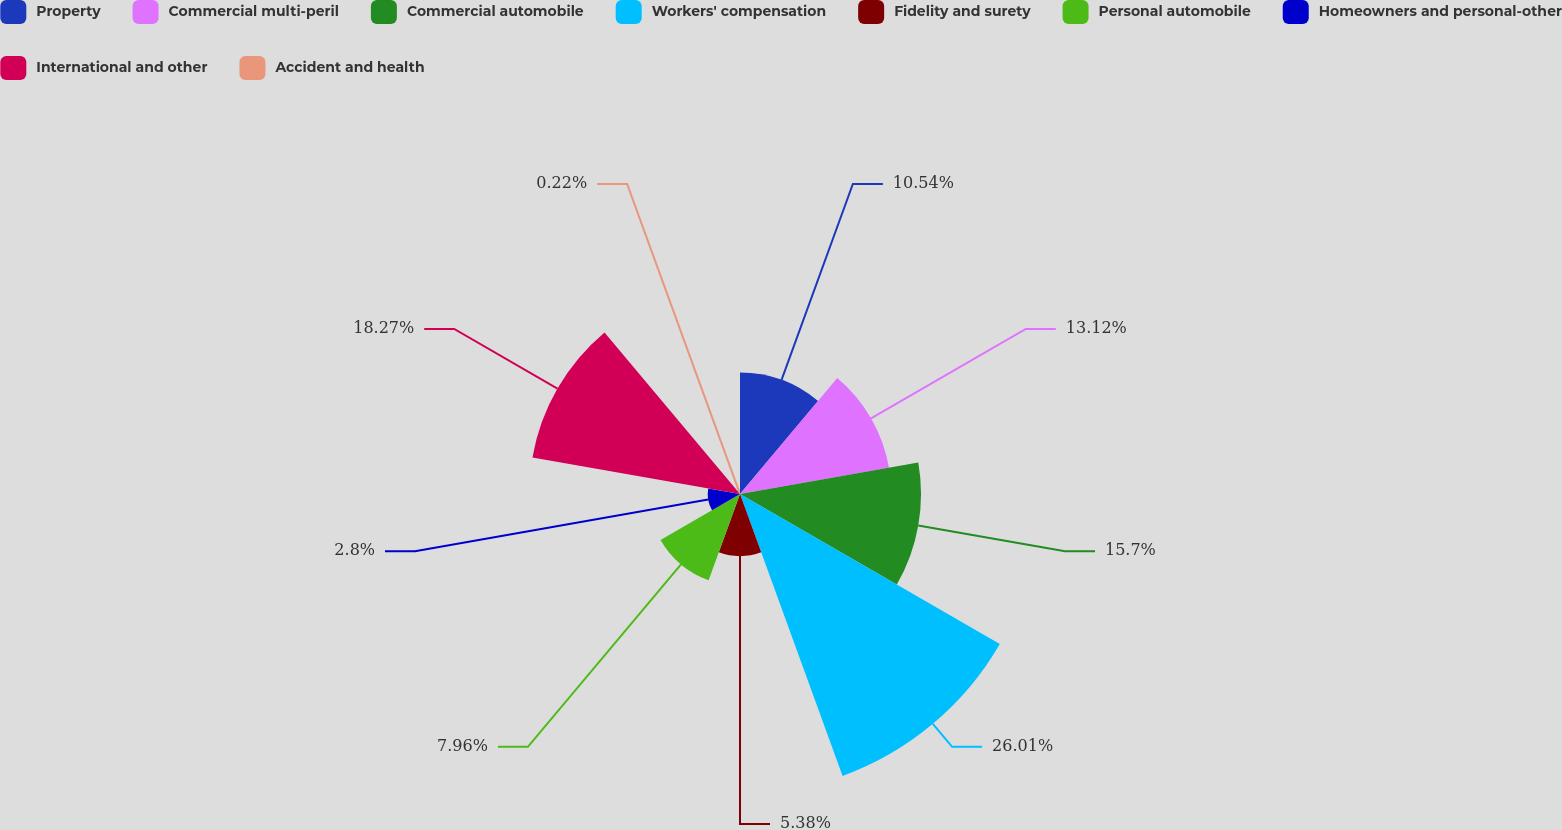<chart> <loc_0><loc_0><loc_500><loc_500><pie_chart><fcel>Property<fcel>Commercial multi-peril<fcel>Commercial automobile<fcel>Workers' compensation<fcel>Fidelity and surety<fcel>Personal automobile<fcel>Homeowners and personal-other<fcel>International and other<fcel>Accident and health<nl><fcel>10.54%<fcel>13.12%<fcel>15.7%<fcel>26.02%<fcel>5.38%<fcel>7.96%<fcel>2.8%<fcel>18.28%<fcel>0.22%<nl></chart> 